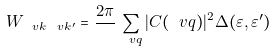Convert formula to latex. <formula><loc_0><loc_0><loc_500><loc_500>W _ { \ v k \ v k ^ { \prime } } = \frac { 2 \pi } { } \sum _ { \ v q } | C ( \ v q ) | ^ { 2 } \Delta ( \varepsilon , \varepsilon ^ { \prime } )</formula> 